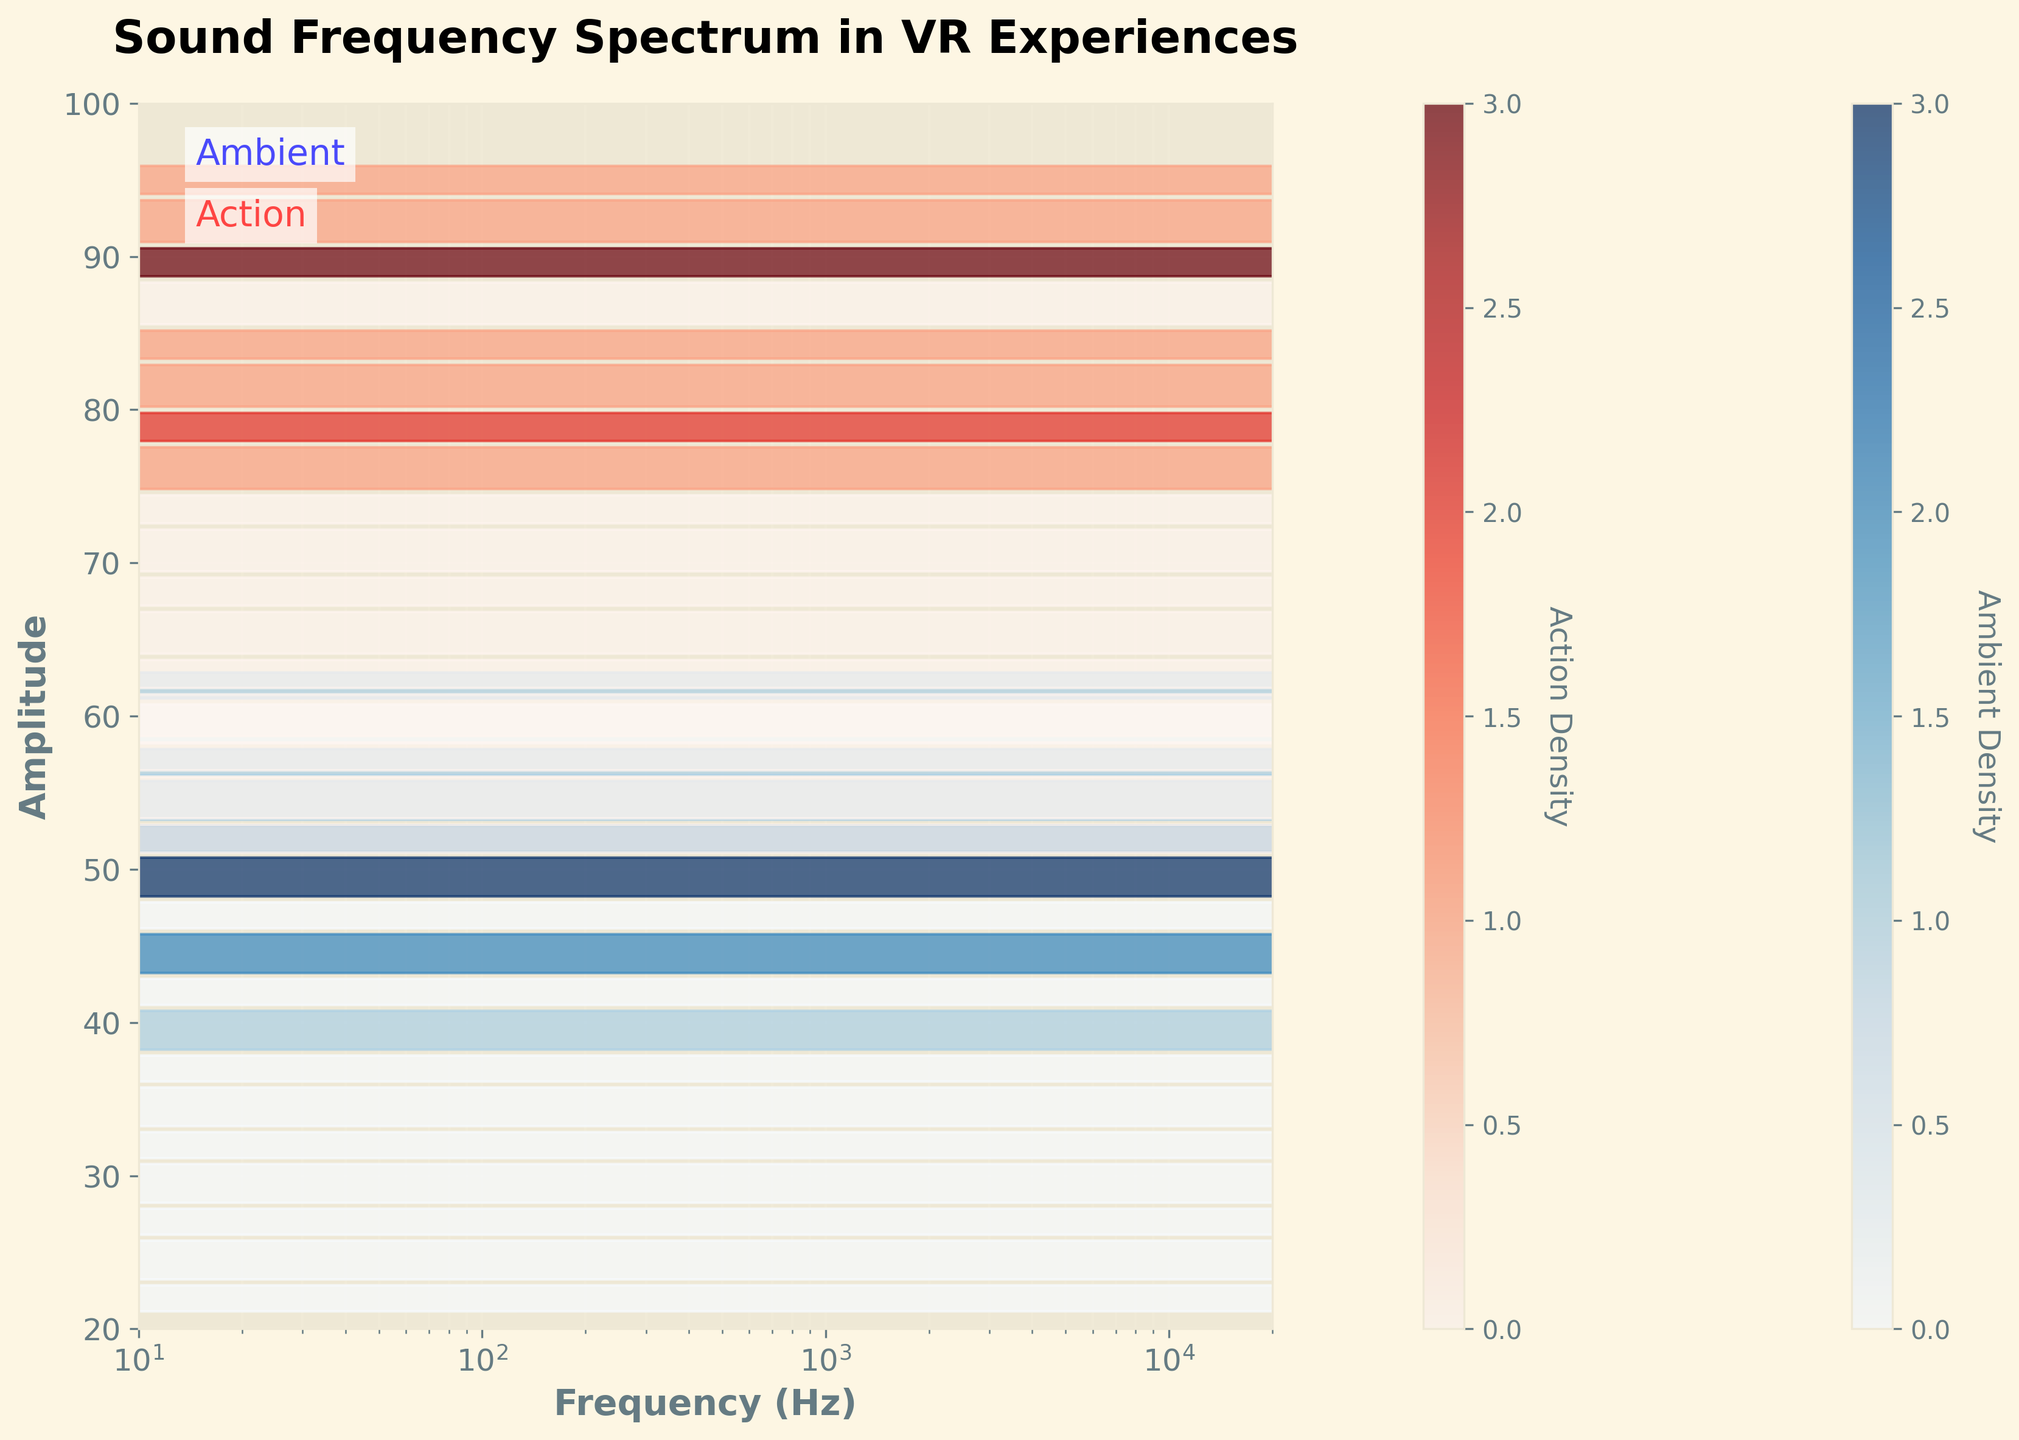What is the title of the plot? The title is displayed at the top of the plot. It is written in a larger font compared to other text elements to indicate it is the title.
Answer: Sound Frequency Spectrum in VR Experiences Which color represents the ambient sequences in the plot? The color used to represent ambient sequences is indicated by the color density of the hexagons and the color label in the color bar on the right side of the plot.
Answer: Blue What is the range of the y-axis? The y-axis range can be determined by looking at the minimum and maximum values marked on the y-axis.
Answer: 20 to 100 How many distinct color bars are shown in the plot? The two color bars represent the density of the two categories. Each category has a different color bar to show its respective density.
Answer: 2 How does the density of amplitude for action sequences compare to ambient sequences around 100 Hz? The density can be compared by looking at the intensity of the color in the hexagons around 100 Hz for both categories.
Answer: Higher in action sequences Which sequence type shows higher amplitudes at higher frequencies around 10000 Hz? By comparing the color density of hexagons at 10000 Hz for both sequences, one can see which has higher amplitude.
Answer: Action What is the trend of amplitude for ambient sequences as frequency increases? Observing the color density gradient and the positions of hexagons, one can assess the change in amplitude across different frequency ranges.
Answer: Decreases How does the amplitude distribution differ between ambient and action sequences across the frequency range? Compare the density patterns and amplitudes for both sequences at different points on the x-axis (frequency).
Answer: Action sequences generally have higher amplitudes At what frequency does the ambient sequence show the highest density? Identify the peak color density for the blue hexagons along the x-axis.
Answer: 50 Hz What can you infer about the difference in sound design for ambient and action scenes in VR based on this plot? Analyzing the overall density patterns, amplitude ranges, and distributions, one can infer differences in how sound is utilized to create different experiences in VR.
Answer: Action scenes use higher and denser amplitudes 